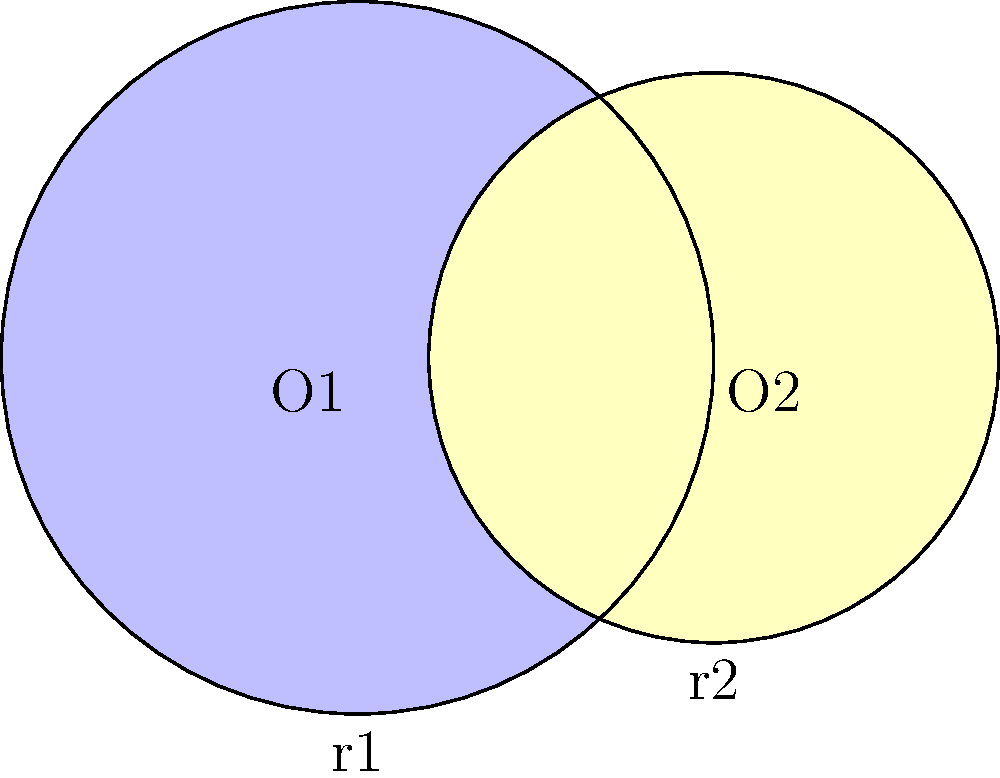In a circular mandala design, two intersecting circles represent the interconnectedness of all things. The larger circle, centered at O1, has a radius of 10 cm, while the smaller circle, centered at O2, has a radius of 8 cm. If the distance between the centers is 6 cm, what is the area of the region where the circles overlap (the lens-shaped region)? Express your answer in terms of π cm². To find the area of the overlapping region, we'll follow these steps:

1) First, we need to find the central angle for each circle. Let's call these angles $\theta_1$ and $\theta_2$.

2) We can find these angles using the cosine law:
   
   For the larger circle: $\cos(\frac{\theta_1}{2}) = \frac{6^2 + 10^2 - 8^2}{2 * 6 * 10} = \frac{5}{6}$
   
   For the smaller circle: $\cos(\frac{\theta_2}{2}) = \frac{6^2 + 8^2 - 10^2}{2 * 6 * 8} = \frac{1}{4}$

3) We can find $\theta_1$ and $\theta_2$ using arccos:
   
   $\theta_1 = 2 * \arccos(\frac{5}{6}) \approx 1.2870$ radians
   
   $\theta_2 = 2 * \arccos(\frac{1}{4}) \approx 2.5862$ radians

4) The area of a circular sector is given by $\frac{1}{2}r^2\theta$, where $r$ is the radius and $\theta$ is the central angle in radians.

5) The area of the lens-shaped region is the sum of the two sectors minus the area of the rhombus formed by the radii:
   
   $A = \frac{1}{2}(10^2 * 1.2870 + 8^2 * 2.5862) - \frac{1}{2}(6 * 6 * \sin(1.2870))$

6) Calculating this:
   
   $A \approx 64.35 + 82.76 - 17.89 = 129.22$ cm²

7) Expressing in terms of π:
   
   $129.22 \approx 41.11π$ cm²

Therefore, the area of the overlapping region is approximately $41π$ cm².
Answer: $41π$ cm² 